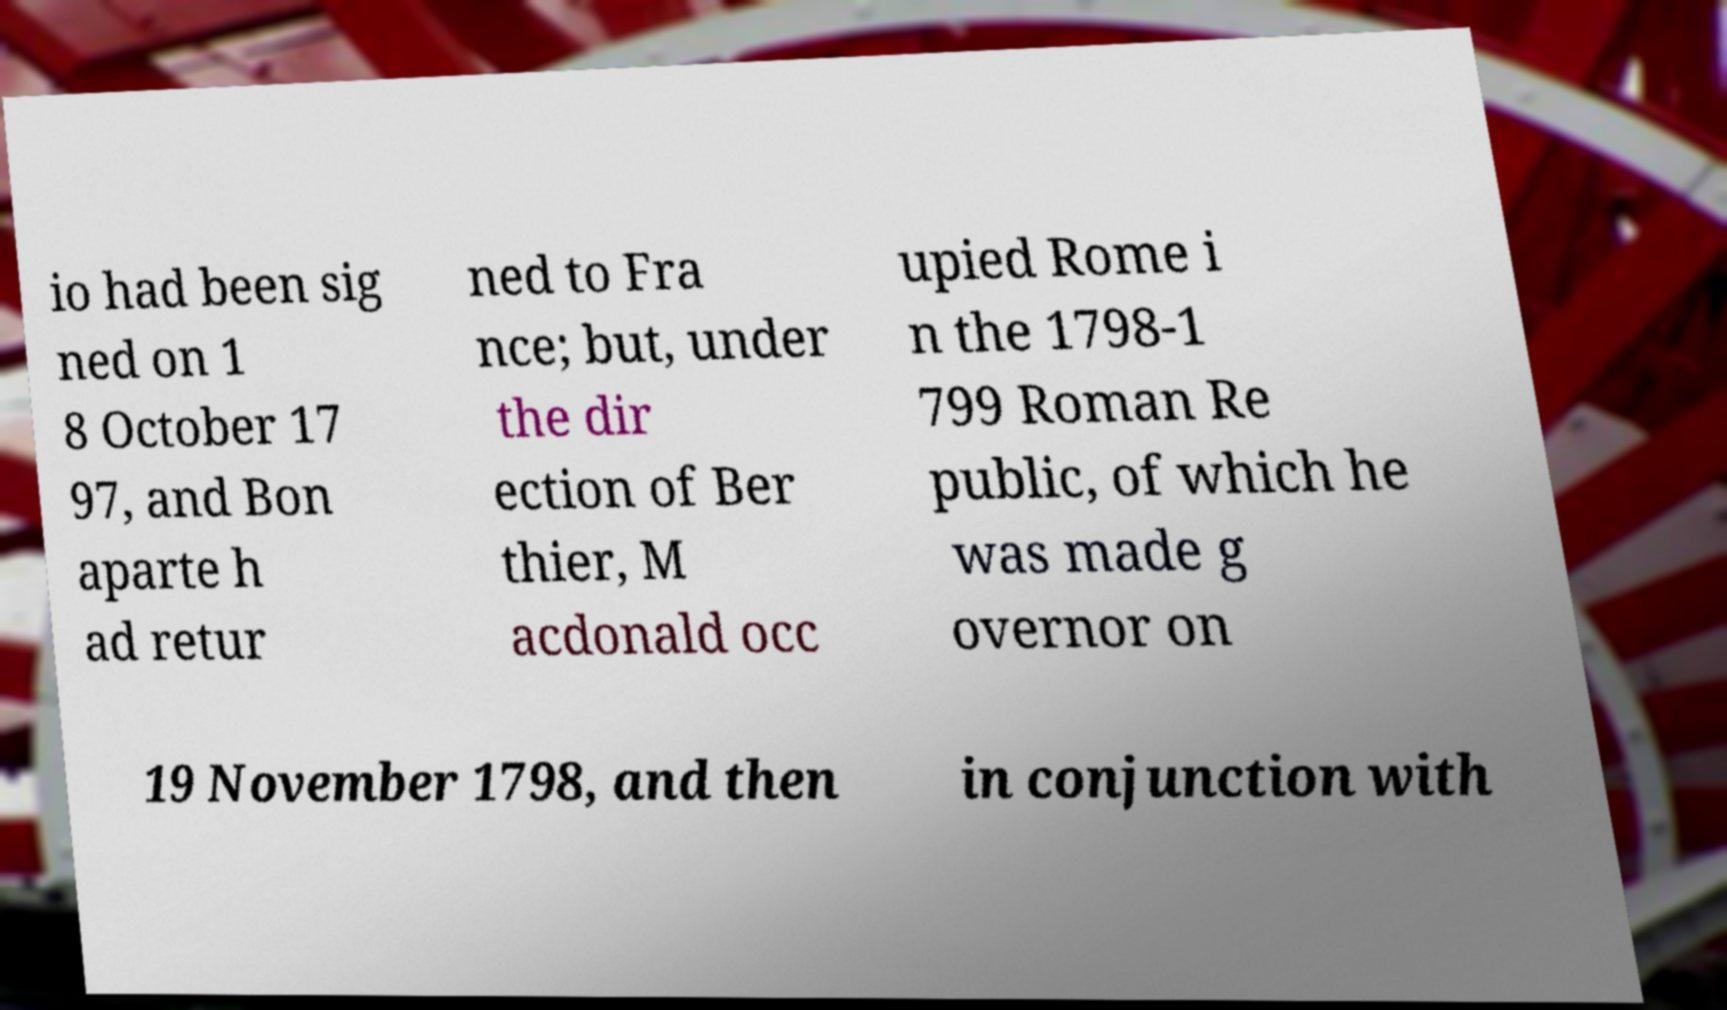Please read and relay the text visible in this image. What does it say? io had been sig ned on 1 8 October 17 97, and Bon aparte h ad retur ned to Fra nce; but, under the dir ection of Ber thier, M acdonald occ upied Rome i n the 1798-1 799 Roman Re public, of which he was made g overnor on 19 November 1798, and then in conjunction with 